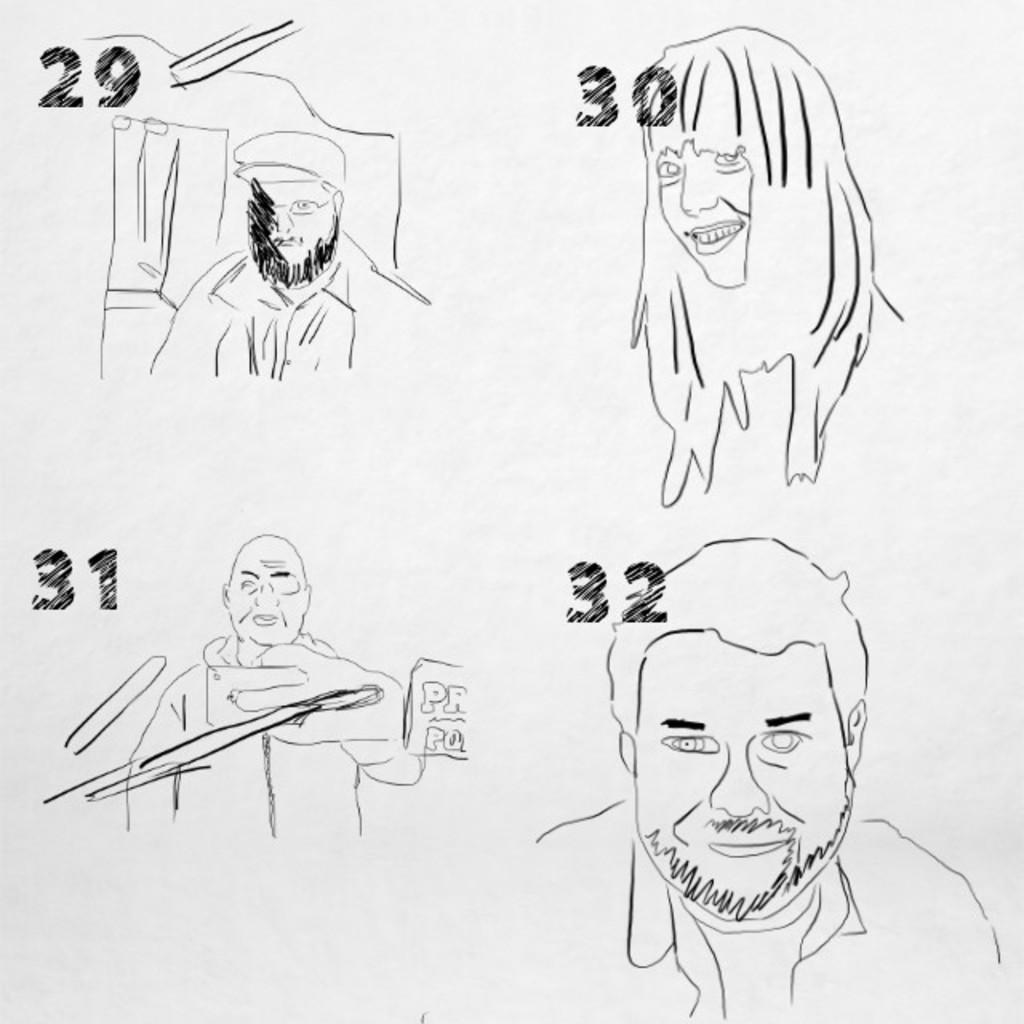What is present in the image? There is a poster in the image. What can be seen on the poster? The poster contains faces of different people. What type of zipper is used on the coat in the image? There is no coat or zipper present in the image; it only features a poster with faces of different people. What is the cook preparing in the image? There is no cook or food preparation visible in the image. 